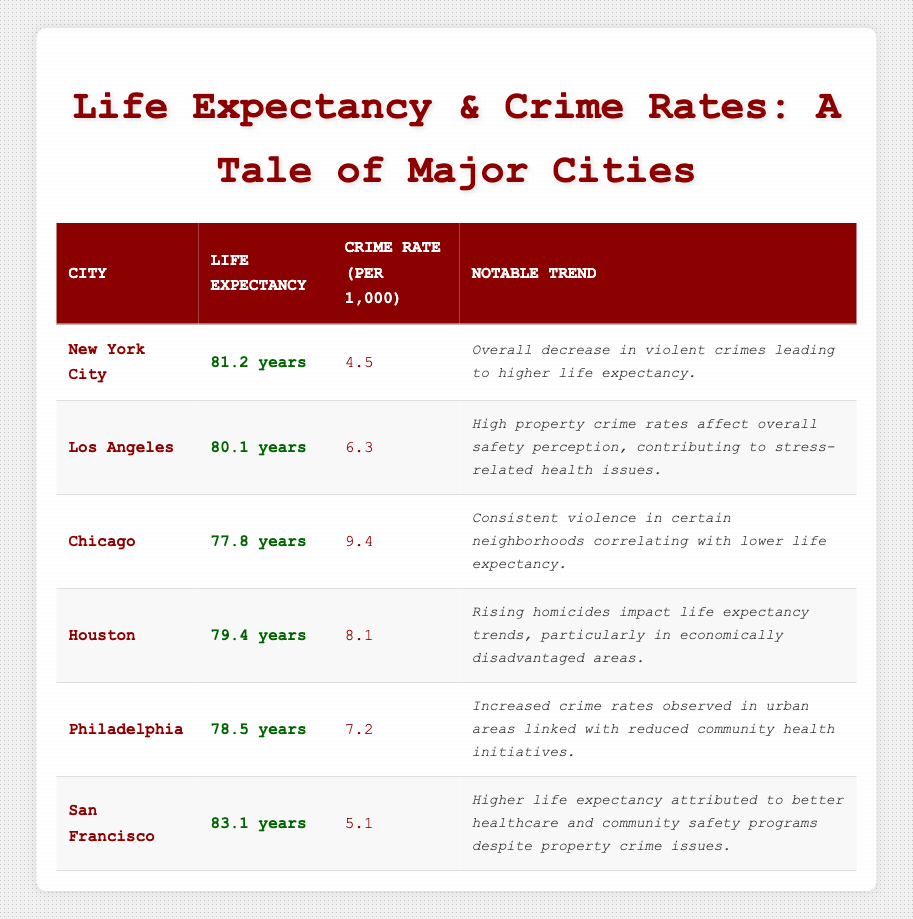What is the life expectancy in San Francisco? According to the table, the life expectancy listed for San Francisco is 83.1 years.
Answer: 83.1 years Which city has the highest crime rate? The highest crime rate in the table is 9.4, which corresponds to Chicago.
Answer: Chicago Is it true that New York City has a higher life expectancy than Philadelphia? Comparing the life expectancy values, New York City (81.2 years) is greater than Philadelphia (78.5 years), so this statement is true.
Answer: Yes What is the average life expectancy of the cities listed? The life expectancies are: 81.2 (NYC), 80.1 (LA), 77.8 (Chicago), 79.4 (Houston), 78.5 (Philadelphia), and 83.1 (San Francisco). Summing these gives 480.1. Dividing by the number of cities (6) results in an average of 80.01667, which rounds to approximately 80.0 years.
Answer: 80.0 years What notable trend is associated with life expectancy in Houston? The notable trend indicated for Houston is that rising homicides are impacting life expectancy trends, particularly in economically disadvantaged areas.
Answer: Rising homicides decrease life expectancy Which city experienced a notable decrease in violent crimes leading to higher life expectancy? The table states that New York City is experiencing an overall decrease in violent crimes, which has led to a higher life expectancy.
Answer: New York City How does the crime rate in Los Angeles compare to that of Philadelphia? The crime rate of Los Angeles is 6.3, while Philadelphia's crime rate is 7.2. Therefore, Los Angeles has a lower crime rate than Philadelphia.
Answer: Lower If we consider cities with life expectancy over 80 years, how many cities are there? The cities with life expectancy over 80 years are New York City (81.2 years) and San Francisco (83.1 years), totaling 2 cities that meet this criterion.
Answer: 2 cities What health issues are linked to crime rates in Los Angeles? The table indicates that high property crime rates affect the overall safety perception in Los Angeles, contributing to stress-related health issues.
Answer: Stress-related health issues 